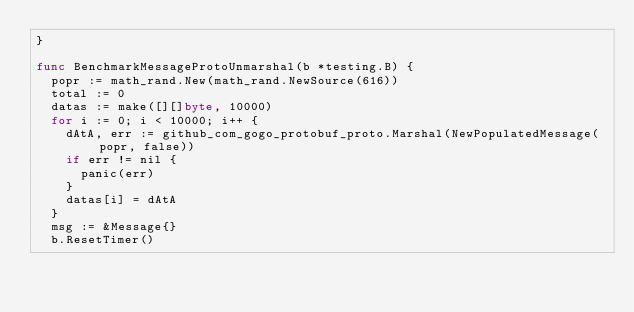Convert code to text. <code><loc_0><loc_0><loc_500><loc_500><_Go_>}

func BenchmarkMessageProtoUnmarshal(b *testing.B) {
	popr := math_rand.New(math_rand.NewSource(616))
	total := 0
	datas := make([][]byte, 10000)
	for i := 0; i < 10000; i++ {
		dAtA, err := github_com_gogo_protobuf_proto.Marshal(NewPopulatedMessage(popr, false))
		if err != nil {
			panic(err)
		}
		datas[i] = dAtA
	}
	msg := &Message{}
	b.ResetTimer()</code> 